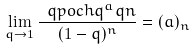Convert formula to latex. <formula><loc_0><loc_0><loc_500><loc_500>\lim _ { q \to 1 } \frac { \ q p o c h { q ^ { a } } { q } { n } } { ( 1 - q ) ^ { n } } = ( a ) _ { n }</formula> 